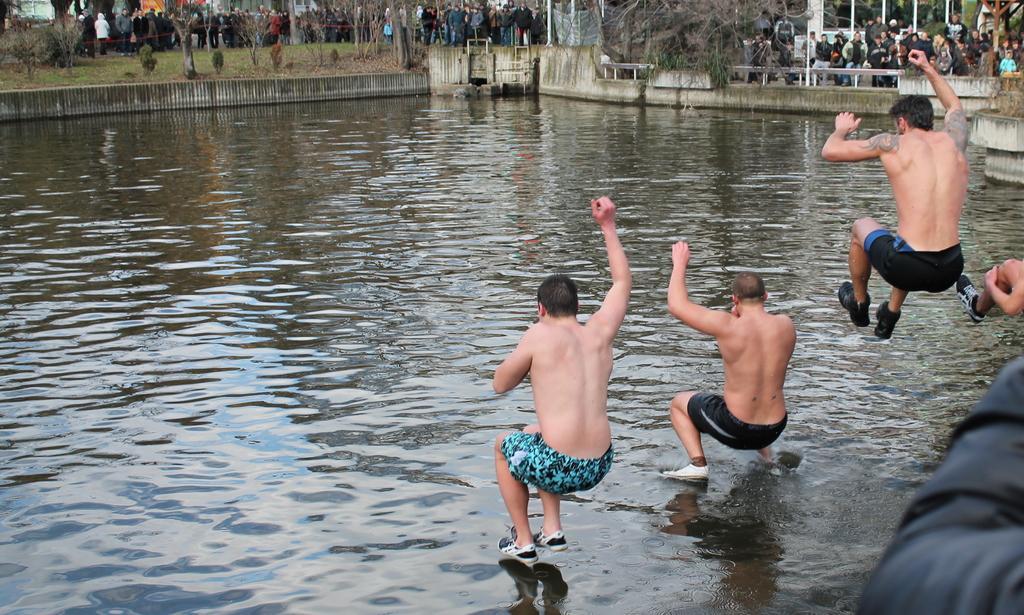How would you summarize this image in a sentence or two? In this image there are four persons jumping into a lake, in the background there are trees and people. 